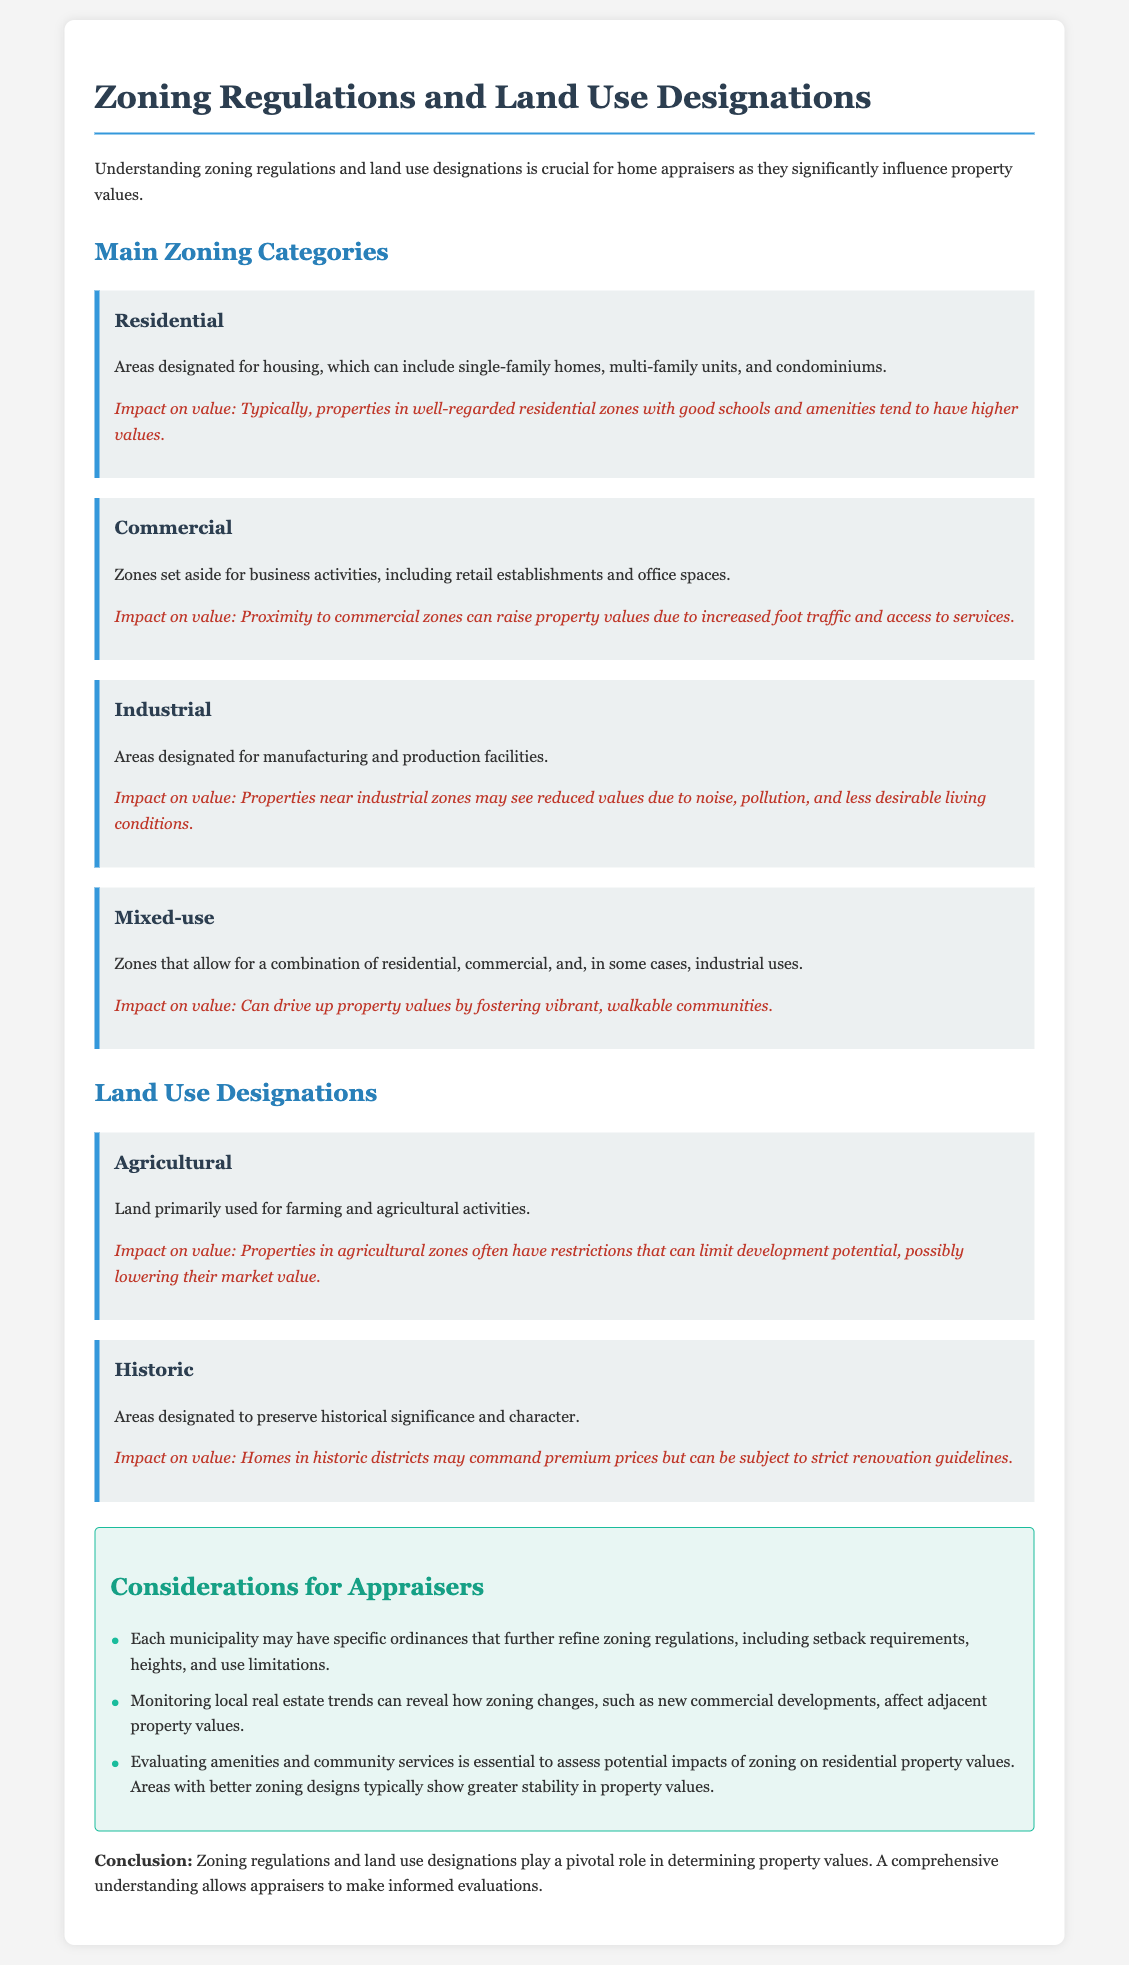What are the main zoning categories mentioned? The document lists the main zoning categories as Residential, Commercial, Industrial, and Mixed-use.
Answer: Residential, Commercial, Industrial, Mixed-use What is the impact of being in a good residential zone? The document states that properties in well-regarded residential zones with good schools and amenities tend to have higher values.
Answer: Higher values What does agricultural land primarily used for? The document specifies that agricultural land is primarily used for farming and agricultural activities.
Answer: Farming and agricultural activities What can be a consequence of properties near industrial zones? The document indicates that properties near industrial zones may see reduced values due to noise, pollution, and less desirable living conditions.
Answer: Reduced values What is a unique feature of historic zones? The document notes that homes in historic districts may command premium prices but can be subject to strict renovation guidelines.
Answer: Command premium prices, strict renovation guidelines Which category could drive up property values by fostering vibrant communities? According to the document, Mixed-use zones can drive up property values by fostering vibrant, walkable communities.
Answer: Mixed-use What considerations should appraisers keep in mind regarding zoning? The document suggests that appraisers should monitor local real estate trends and evaluate amenities and community services related to zoning impacts.
Answer: Monitor trends, evaluate amenities How do zoning regulations influence property values? The document concludes that zoning regulations and land use designations play a pivotal role in determining property values.
Answer: Pivotal role How many considerations for appraisers are listed in the document? The document mentions three specific considerations for appraisers within the considerations section.
Answer: Three 